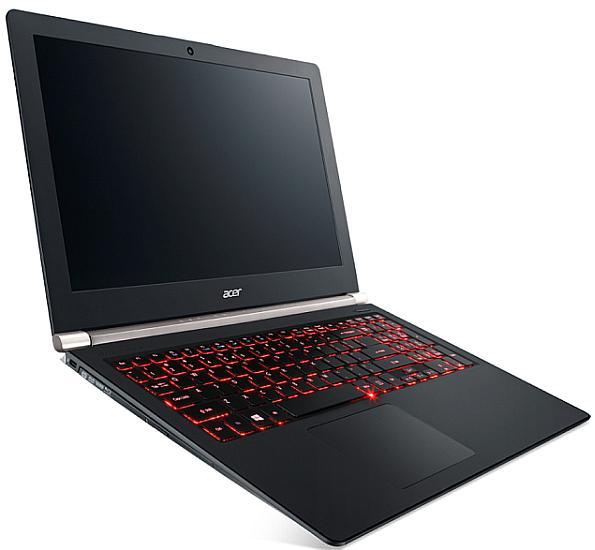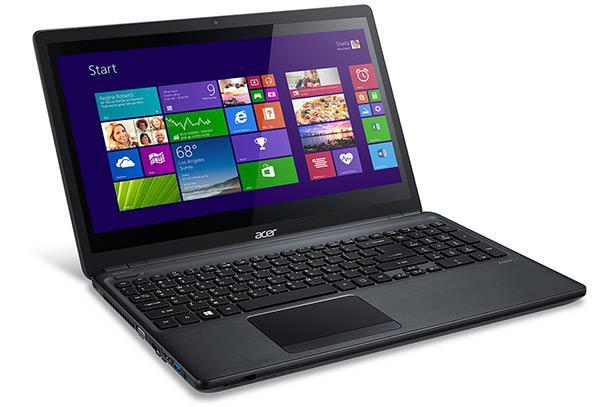The first image is the image on the left, the second image is the image on the right. Evaluate the accuracy of this statement regarding the images: "The laptop on the right displays the tiles from the operating system Windows.". Is it true? Answer yes or no. Yes. 